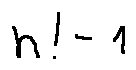Convert formula to latex. <formula><loc_0><loc_0><loc_500><loc_500>n ! - 1</formula> 